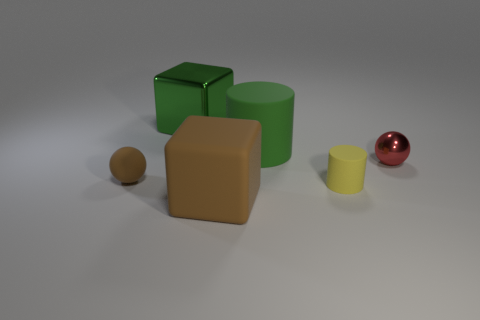Is the material of the large block that is in front of the small red shiny thing the same as the large green block?
Your answer should be very brief. No. Is the number of large brown matte things behind the small red shiny ball less than the number of large green metal cylinders?
Offer a very short reply. No. What is the color of the other rubber thing that is the same size as the green matte thing?
Offer a terse response. Brown. How many small metal objects are the same shape as the tiny brown rubber object?
Make the answer very short. 1. What color is the cube that is in front of the yellow rubber cylinder?
Your response must be concise. Brown. How many matte things are big green cylinders or red balls?
Keep it short and to the point. 1. There is a rubber thing that is the same color as the rubber ball; what is its shape?
Provide a short and direct response. Cube. What number of green rubber cylinders are the same size as the brown matte cube?
Keep it short and to the point. 1. There is a thing that is both behind the red shiny object and left of the large brown matte cube; what is its color?
Provide a succinct answer. Green. What number of things are small red objects or small green matte cylinders?
Your answer should be compact. 1. 